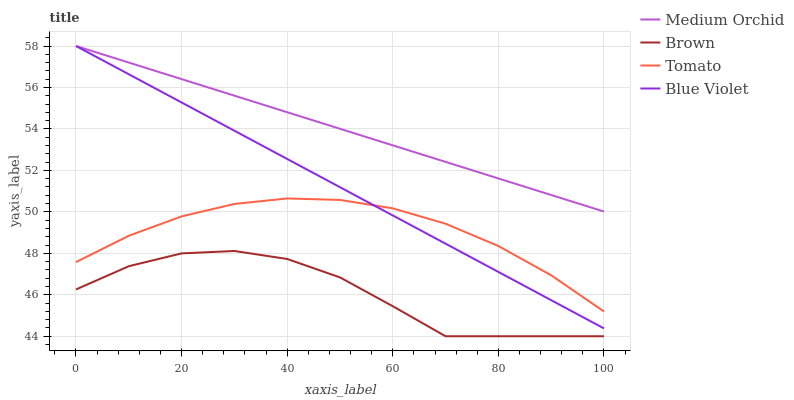Does Brown have the minimum area under the curve?
Answer yes or no. Yes. Does Medium Orchid have the maximum area under the curve?
Answer yes or no. Yes. Does Medium Orchid have the minimum area under the curve?
Answer yes or no. No. Does Brown have the maximum area under the curve?
Answer yes or no. No. Is Medium Orchid the smoothest?
Answer yes or no. Yes. Is Brown the roughest?
Answer yes or no. Yes. Is Brown the smoothest?
Answer yes or no. No. Is Medium Orchid the roughest?
Answer yes or no. No. Does Brown have the lowest value?
Answer yes or no. Yes. Does Medium Orchid have the lowest value?
Answer yes or no. No. Does Blue Violet have the highest value?
Answer yes or no. Yes. Does Brown have the highest value?
Answer yes or no. No. Is Tomato less than Medium Orchid?
Answer yes or no. Yes. Is Medium Orchid greater than Tomato?
Answer yes or no. Yes. Does Blue Violet intersect Medium Orchid?
Answer yes or no. Yes. Is Blue Violet less than Medium Orchid?
Answer yes or no. No. Is Blue Violet greater than Medium Orchid?
Answer yes or no. No. Does Tomato intersect Medium Orchid?
Answer yes or no. No. 